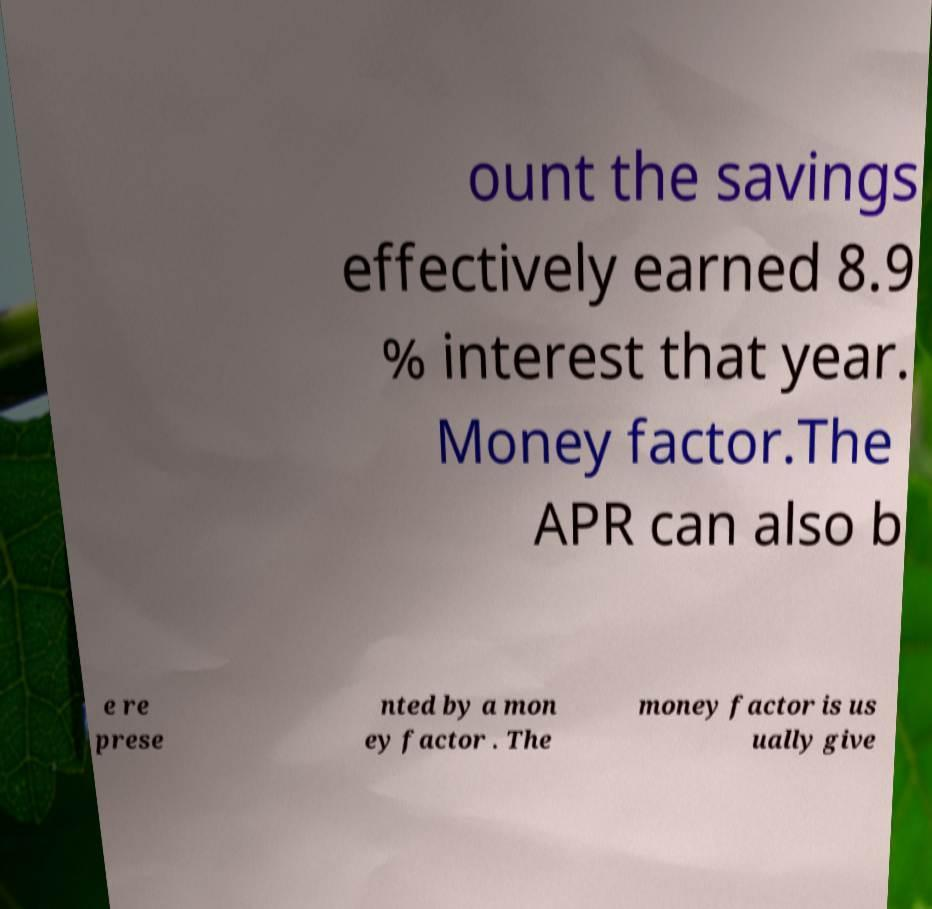Can you read and provide the text displayed in the image?This photo seems to have some interesting text. Can you extract and type it out for me? ount the savings effectively earned 8.9 % interest that year. Money factor.The APR can also b e re prese nted by a mon ey factor . The money factor is us ually give 